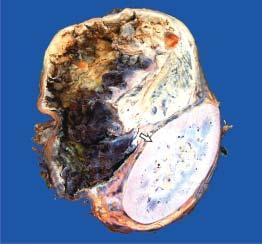do solid areas show dark brown, necrotic and haemorrhagic tumour?
Answer the question using a single word or phrase. Yes 